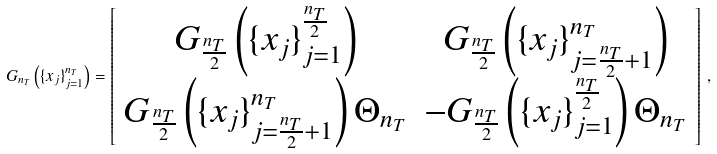Convert formula to latex. <formula><loc_0><loc_0><loc_500><loc_500>G _ { n _ { T } } \left ( \{ x _ { j } \} _ { j = 1 } ^ { n _ { T } } \right ) = \left [ \begin{array} { * { 2 } { c } } G _ { \frac { n _ { T } } { 2 } } \left ( \{ x _ { j } \} _ { j = 1 } ^ { \frac { n _ { T } } { 2 } } \right ) & G _ { \frac { n _ { T } } { 2 } } \left ( \{ x _ { j } \} _ { j = \frac { n _ { T } } { 2 } + 1 } ^ { n _ { T } } \right ) \\ G _ { \frac { n _ { T } } { 2 } } \left ( \{ x _ { j } \} _ { j = \frac { n _ { T } } { 2 } + 1 } ^ { n _ { T } } \right ) \Theta _ { n _ { T } } & - G _ { \frac { n _ { T } } { 2 } } \left ( \{ x _ { j } \} _ { j = 1 } ^ { \frac { n _ { T } } { 2 } } \right ) \Theta _ { n _ { T } } \\ \end{array} \right ] \, ,</formula> 